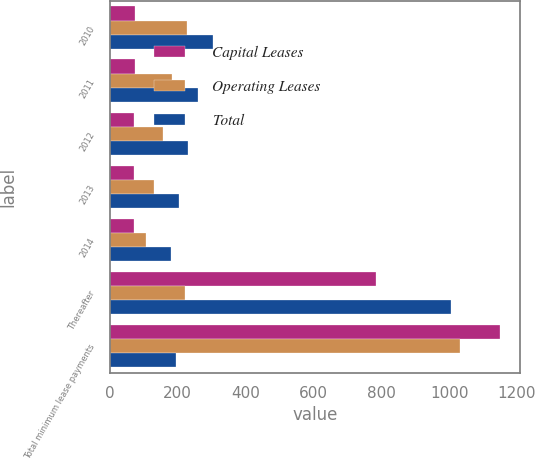Convert chart. <chart><loc_0><loc_0><loc_500><loc_500><stacked_bar_chart><ecel><fcel>2010<fcel>2011<fcel>2012<fcel>2013<fcel>2014<fcel>Thereafter<fcel>Total minimum lease payments<nl><fcel>Capital Leases<fcel>74<fcel>75<fcel>72<fcel>72<fcel>73<fcel>785<fcel>1151<nl><fcel>Operating Leases<fcel>229<fcel>184<fcel>158<fcel>132<fcel>108<fcel>222<fcel>1033<nl><fcel>Total<fcel>303<fcel>259<fcel>230<fcel>204<fcel>181<fcel>1007<fcel>194<nl></chart> 